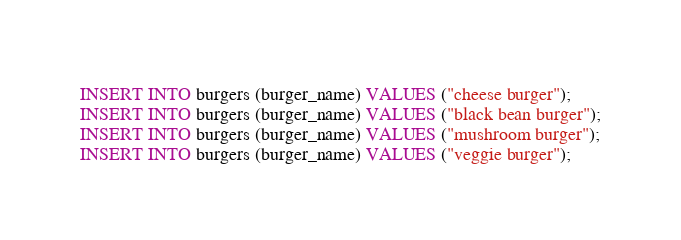<code> <loc_0><loc_0><loc_500><loc_500><_SQL_>INSERT INTO burgers (burger_name) VALUES ("cheese burger");
INSERT INTO burgers (burger_name) VALUES ("black bean burger");
INSERT INTO burgers (burger_name) VALUES ("mushroom burger");
INSERT INTO burgers (burger_name) VALUES ("veggie burger");
</code> 